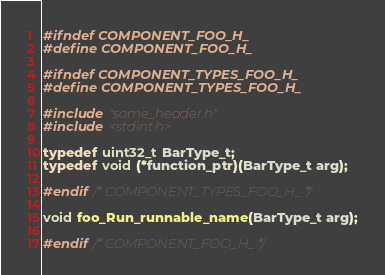<code> <loc_0><loc_0><loc_500><loc_500><_C_>#ifndef COMPONENT_FOO_H_
#define COMPONENT_FOO_H_

#ifndef COMPONENT_TYPES_FOO_H_
#define COMPONENT_TYPES_FOO_H_

#include "some_header.h"
#include <stdint.h>

typedef uint32_t BarType_t;
typedef void (*function_ptr)(BarType_t arg);

#endif /* COMPONENT_TYPES_FOO_H_ */

void foo_Run_runnable_name(BarType_t arg);

#endif /* COMPONENT_FOO_H_ */
</code> 